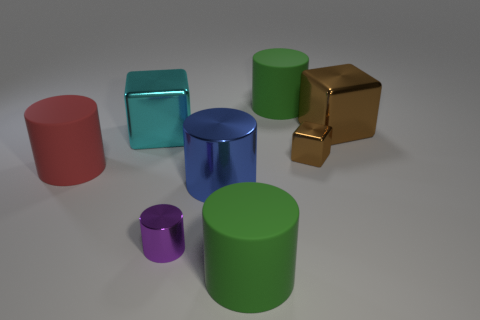There is a red object; is its shape the same as the brown thing that is in front of the cyan metallic thing?
Your response must be concise. No. Is the number of big brown metal things that are on the left side of the small purple cylinder the same as the number of cyan cubes in front of the big blue metal cylinder?
Give a very brief answer. Yes. What shape is the metallic thing that is the same color as the tiny cube?
Ensure brevity in your answer.  Cube. There is a large block on the left side of the large brown metallic object; is its color the same as the large cylinder left of the purple cylinder?
Offer a very short reply. No. Is the number of big cyan shiny cubes right of the tiny purple thing greater than the number of large brown things?
Offer a terse response. No. What is the material of the cyan object?
Your answer should be very brief. Metal. What is the shape of the small brown thing that is made of the same material as the big blue object?
Offer a very short reply. Cube. There is a green matte cylinder that is in front of the block behind the large cyan block; how big is it?
Your answer should be compact. Large. There is a metallic block to the left of the tiny cylinder; what color is it?
Give a very brief answer. Cyan. Is there a red matte thing that has the same shape as the tiny purple thing?
Your answer should be very brief. Yes. 